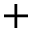<formula> <loc_0><loc_0><loc_500><loc_500>+</formula> 